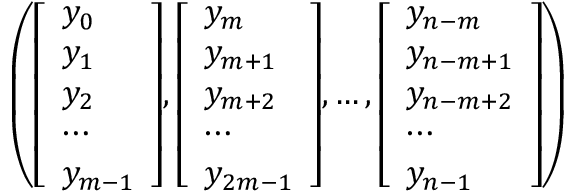<formula> <loc_0><loc_0><loc_500><loc_500>\left ( { \left [ \begin{array} { l } { y _ { 0 } } \\ { y _ { 1 } } \\ { y _ { 2 } } \\ { \cdots } \\ { y _ { m - 1 } } \end{array} \right ] } , { \left [ \begin{array} { l } { y _ { m } } \\ { y _ { m + 1 } } \\ { y _ { m + 2 } } \\ { \cdots } \\ { y _ { 2 m - 1 } } \end{array} \right ] } , \dots , { \left [ \begin{array} { l } { y _ { n - m } } \\ { y _ { n - m + 1 } } \\ { y _ { n - m + 2 } } \\ { \cdots } \\ { y _ { n - 1 } } \end{array} \right ] } \right )</formula> 